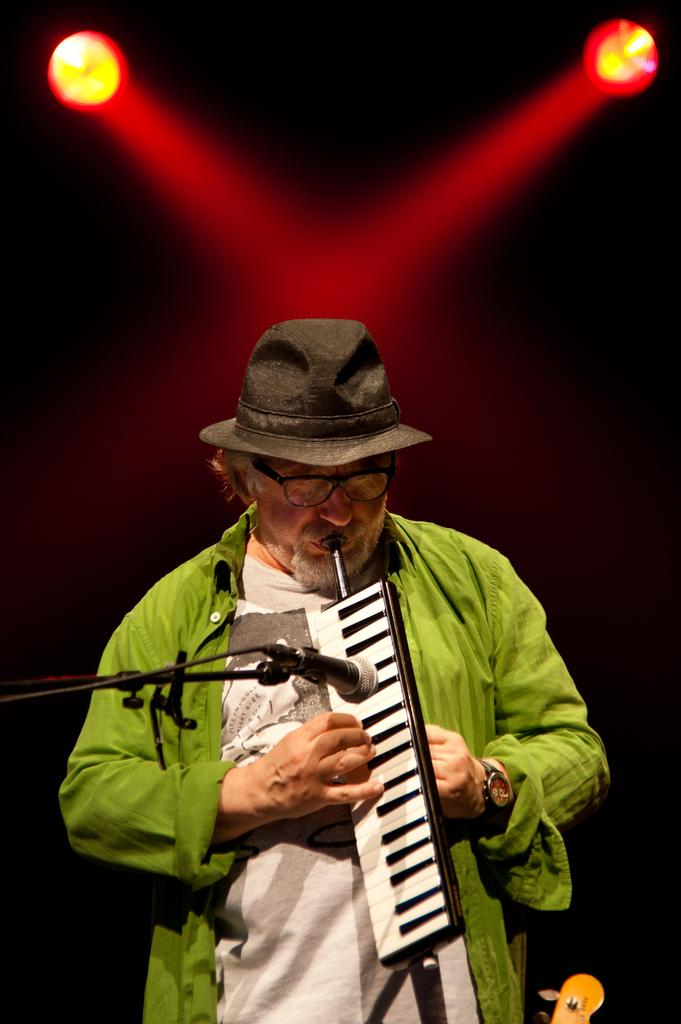What is the man in the image doing? The man is playing a musical instrument in the image. What object is present to amplify the man's voice? There is a microphone on a stand in the image. What type of headwear is the man wearing? The person has a hat on their head. How would you describe the lighting conditions in the image? The background of the image is dark, but there are lights visible in the background. What letter does the man's hat spell out in the image? There is no letter visible on the man's hat in the image. Who is the owner of the musical instrument in the image? The image does not provide information about the ownership of the musical instrument. 